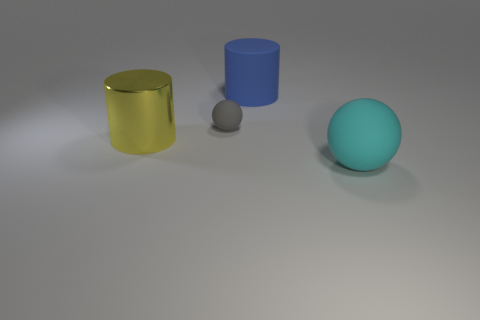Add 4 large metal cylinders. How many objects exist? 8 Subtract all cyan balls. How many balls are left? 1 Subtract 2 balls. How many balls are left? 0 Subtract all yellow cylinders. Subtract all yellow blocks. How many cylinders are left? 1 Subtract all yellow blocks. How many blue cylinders are left? 1 Subtract all yellow things. Subtract all tiny gray cubes. How many objects are left? 3 Add 2 rubber cylinders. How many rubber cylinders are left? 3 Add 4 small gray matte balls. How many small gray matte balls exist? 5 Subtract 1 cyan spheres. How many objects are left? 3 